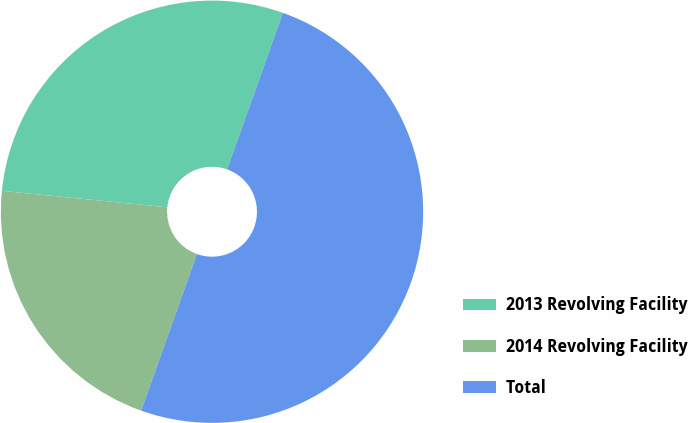<chart> <loc_0><loc_0><loc_500><loc_500><pie_chart><fcel>2013 Revolving Facility<fcel>2014 Revolving Facility<fcel>Total<nl><fcel>28.87%<fcel>21.13%<fcel>50.0%<nl></chart> 